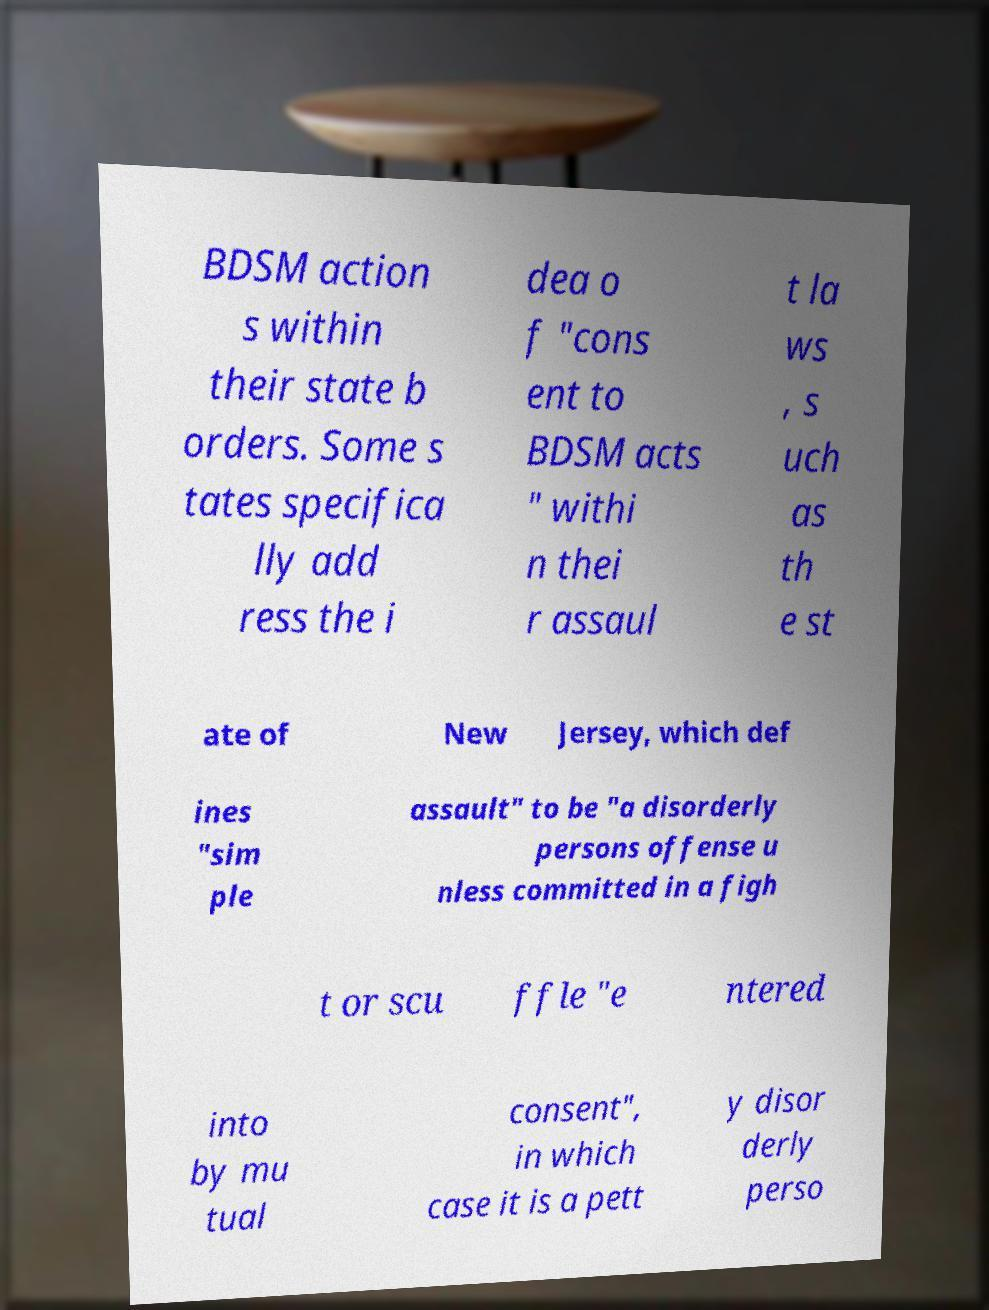Please read and relay the text visible in this image. What does it say? BDSM action s within their state b orders. Some s tates specifica lly add ress the i dea o f "cons ent to BDSM acts " withi n thei r assaul t la ws , s uch as th e st ate of New Jersey, which def ines "sim ple assault" to be "a disorderly persons offense u nless committed in a figh t or scu ffle "e ntered into by mu tual consent", in which case it is a pett y disor derly perso 